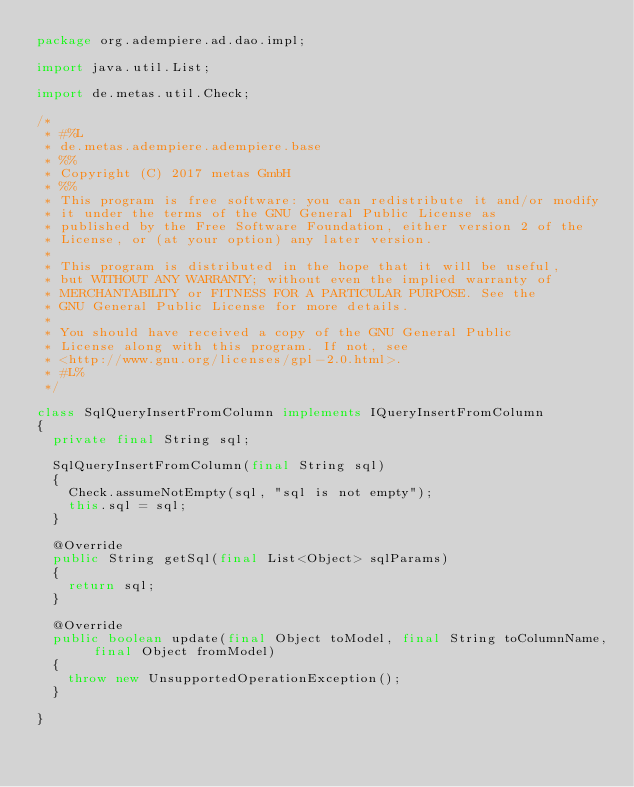<code> <loc_0><loc_0><loc_500><loc_500><_Java_>package org.adempiere.ad.dao.impl;

import java.util.List;

import de.metas.util.Check;

/*
 * #%L
 * de.metas.adempiere.adempiere.base
 * %%
 * Copyright (C) 2017 metas GmbH
 * %%
 * This program is free software: you can redistribute it and/or modify
 * it under the terms of the GNU General Public License as
 * published by the Free Software Foundation, either version 2 of the
 * License, or (at your option) any later version.
 *
 * This program is distributed in the hope that it will be useful,
 * but WITHOUT ANY WARRANTY; without even the implied warranty of
 * MERCHANTABILITY or FITNESS FOR A PARTICULAR PURPOSE. See the
 * GNU General Public License for more details.
 *
 * You should have received a copy of the GNU General Public
 * License along with this program. If not, see
 * <http://www.gnu.org/licenses/gpl-2.0.html>.
 * #L%
 */

class SqlQueryInsertFromColumn implements IQueryInsertFromColumn
{
	private final String sql;

	SqlQueryInsertFromColumn(final String sql)
	{
		Check.assumeNotEmpty(sql, "sql is not empty");
		this.sql = sql;
	}

	@Override
	public String getSql(final List<Object> sqlParams)
	{
		return sql;
	}

	@Override
	public boolean update(final Object toModel, final String toColumnName, final Object fromModel)
	{
		throw new UnsupportedOperationException();
	}

}
</code> 